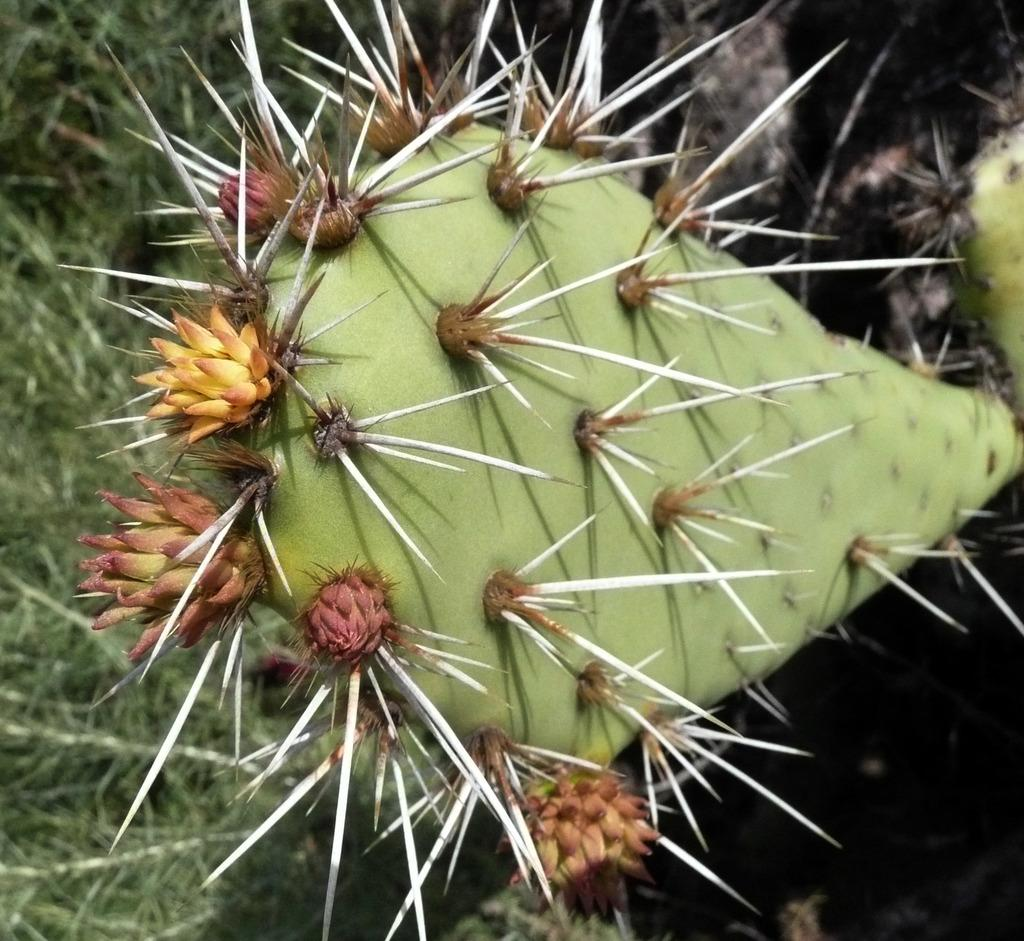What type of vegetation can be seen in the image? There is grass and flowers in the image. Are there any other plants visible in the image? Yes, there is a plant in the image. What feature can be observed on the plant? There are spikes on the plant in the image. Can you see a rat driving a car in the image? No, there is no rat or car present in the image. What is the size of the plant's nose in the image? Plants do not have noses, so this question cannot be answered. 